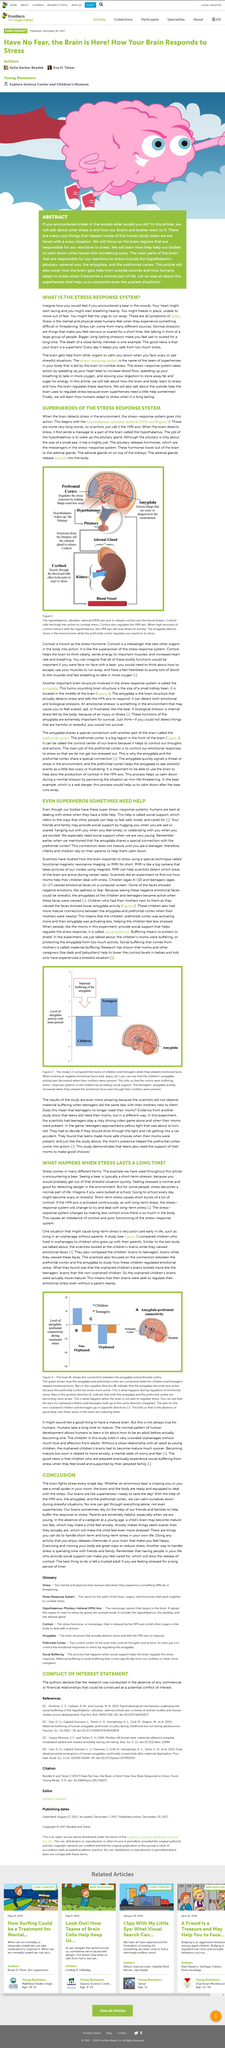List a handful of essential elements in this visual. The study compared the two groups of children, which were orphaned and non-orphaned, to examine the differences in their experiences with war trauma. Functional magnetic resonance imaging, commonly referred to as fMRI, is a non-invasive imaging technique that provides detailed information about the brain's activity by measuring changes in blood flow. The picture compares the brains of children and teenagers. Yes, it does. It is more accurate to say that the orphaned children's minds were considered more developed than those of the children who had not been raised in an orphanage. The increased heart rate and shallow breathing that often accompany stress can be attributed to the brain's attempt to increase oxygen levels in the body. 